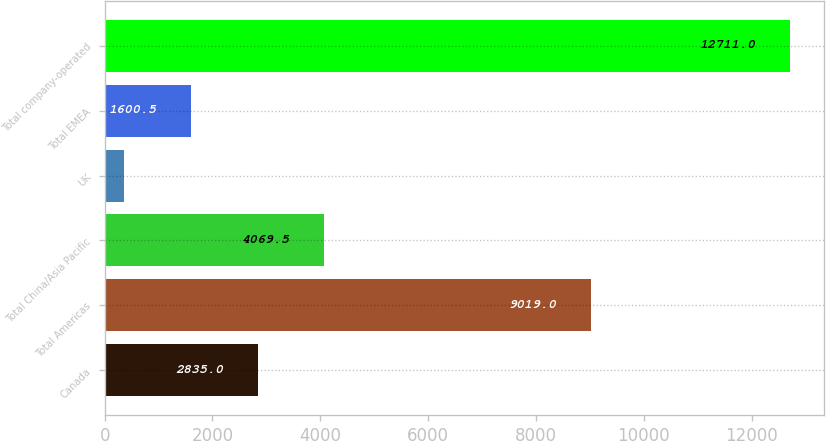<chart> <loc_0><loc_0><loc_500><loc_500><bar_chart><fcel>Canada<fcel>Total Americas<fcel>Total China/Asia Pacific<fcel>UK<fcel>Total EMEA<fcel>Total company-operated<nl><fcel>2835<fcel>9019<fcel>4069.5<fcel>366<fcel>1600.5<fcel>12711<nl></chart> 